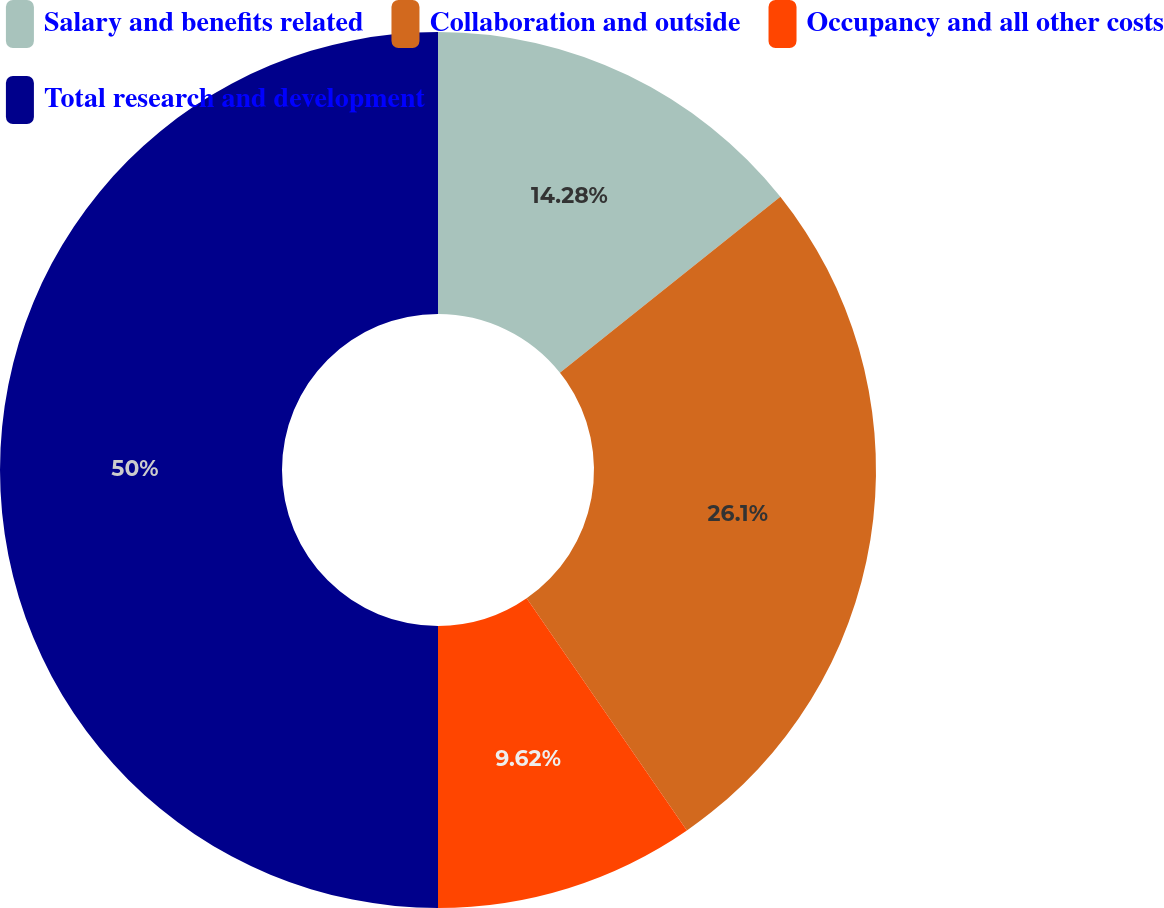Convert chart to OTSL. <chart><loc_0><loc_0><loc_500><loc_500><pie_chart><fcel>Salary and benefits related<fcel>Collaboration and outside<fcel>Occupancy and all other costs<fcel>Total research and development<nl><fcel>14.28%<fcel>26.1%<fcel>9.62%<fcel>50.0%<nl></chart> 